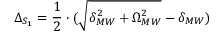Convert formula to latex. <formula><loc_0><loc_0><loc_500><loc_500>\Delta _ { S _ { 1 } } = \frac { 1 } { 2 } \cdot ( \sqrt { \delta _ { M W } ^ { 2 } + \Omega _ { M W } ^ { 2 } } - \delta _ { M W } )</formula> 